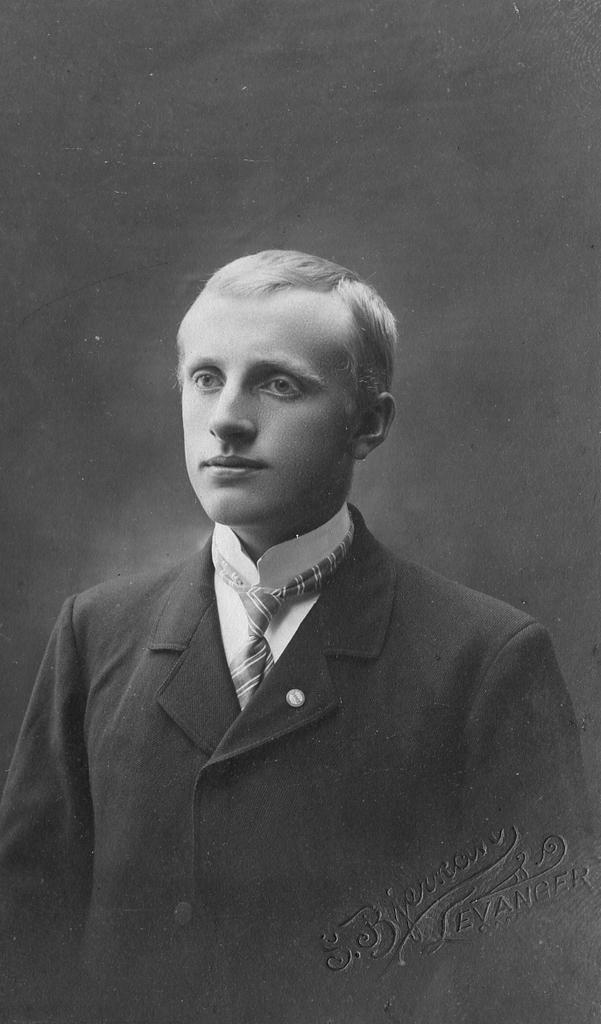Please provide a concise description of this image. In this picture I can see image of a man and a black background and I can see text at the bottom right corner of the picture. 